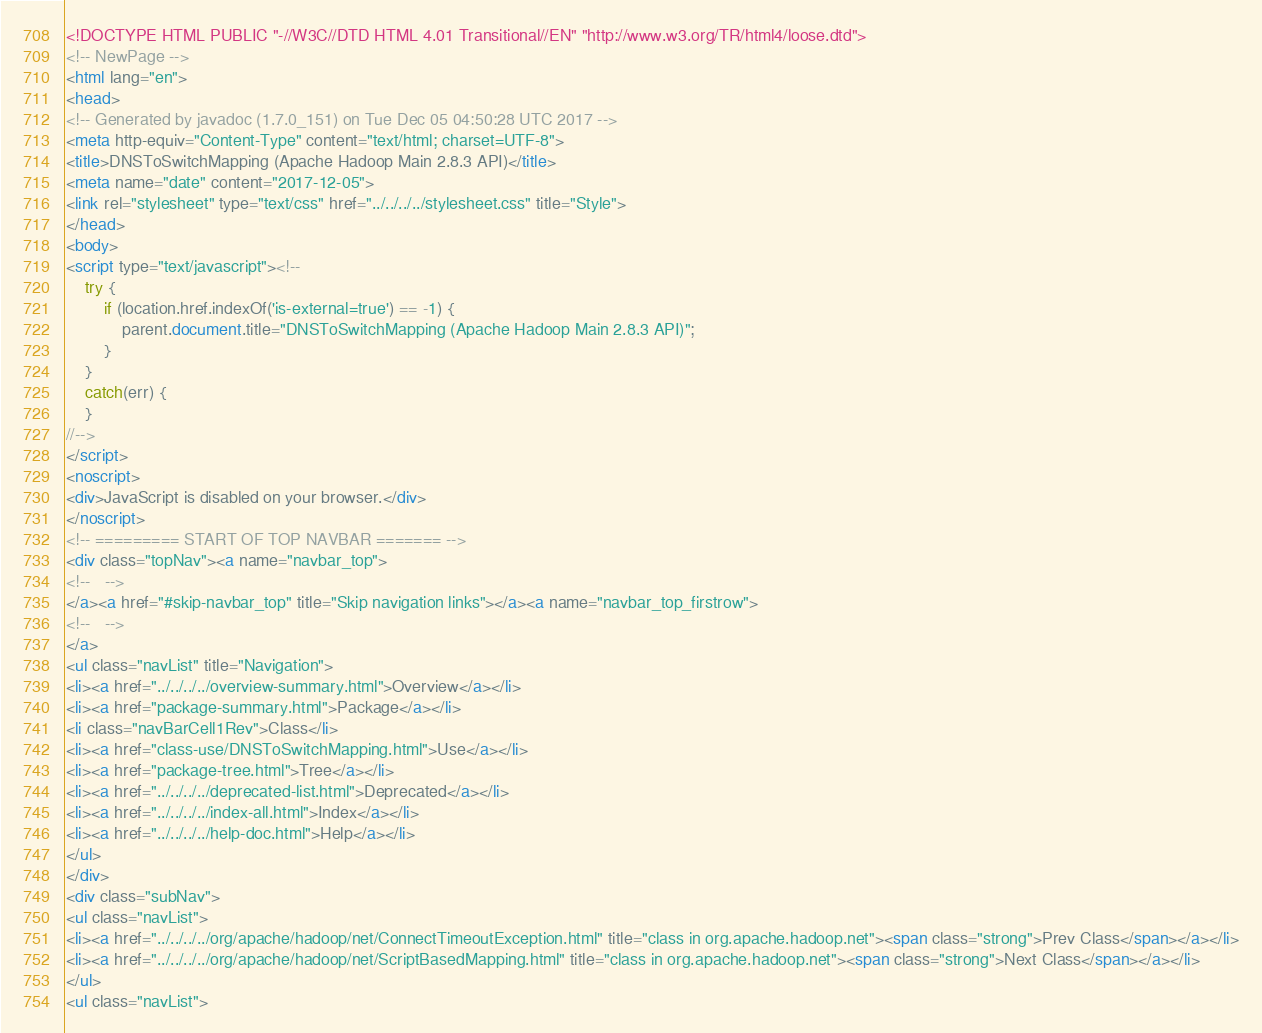Convert code to text. <code><loc_0><loc_0><loc_500><loc_500><_HTML_><!DOCTYPE HTML PUBLIC "-//W3C//DTD HTML 4.01 Transitional//EN" "http://www.w3.org/TR/html4/loose.dtd">
<!-- NewPage -->
<html lang="en">
<head>
<!-- Generated by javadoc (1.7.0_151) on Tue Dec 05 04:50:28 UTC 2017 -->
<meta http-equiv="Content-Type" content="text/html; charset=UTF-8">
<title>DNSToSwitchMapping (Apache Hadoop Main 2.8.3 API)</title>
<meta name="date" content="2017-12-05">
<link rel="stylesheet" type="text/css" href="../../../../stylesheet.css" title="Style">
</head>
<body>
<script type="text/javascript"><!--
    try {
        if (location.href.indexOf('is-external=true') == -1) {
            parent.document.title="DNSToSwitchMapping (Apache Hadoop Main 2.8.3 API)";
        }
    }
    catch(err) {
    }
//-->
</script>
<noscript>
<div>JavaScript is disabled on your browser.</div>
</noscript>
<!-- ========= START OF TOP NAVBAR ======= -->
<div class="topNav"><a name="navbar_top">
<!--   -->
</a><a href="#skip-navbar_top" title="Skip navigation links"></a><a name="navbar_top_firstrow">
<!--   -->
</a>
<ul class="navList" title="Navigation">
<li><a href="../../../../overview-summary.html">Overview</a></li>
<li><a href="package-summary.html">Package</a></li>
<li class="navBarCell1Rev">Class</li>
<li><a href="class-use/DNSToSwitchMapping.html">Use</a></li>
<li><a href="package-tree.html">Tree</a></li>
<li><a href="../../../../deprecated-list.html">Deprecated</a></li>
<li><a href="../../../../index-all.html">Index</a></li>
<li><a href="../../../../help-doc.html">Help</a></li>
</ul>
</div>
<div class="subNav">
<ul class="navList">
<li><a href="../../../../org/apache/hadoop/net/ConnectTimeoutException.html" title="class in org.apache.hadoop.net"><span class="strong">Prev Class</span></a></li>
<li><a href="../../../../org/apache/hadoop/net/ScriptBasedMapping.html" title="class in org.apache.hadoop.net"><span class="strong">Next Class</span></a></li>
</ul>
<ul class="navList"></code> 